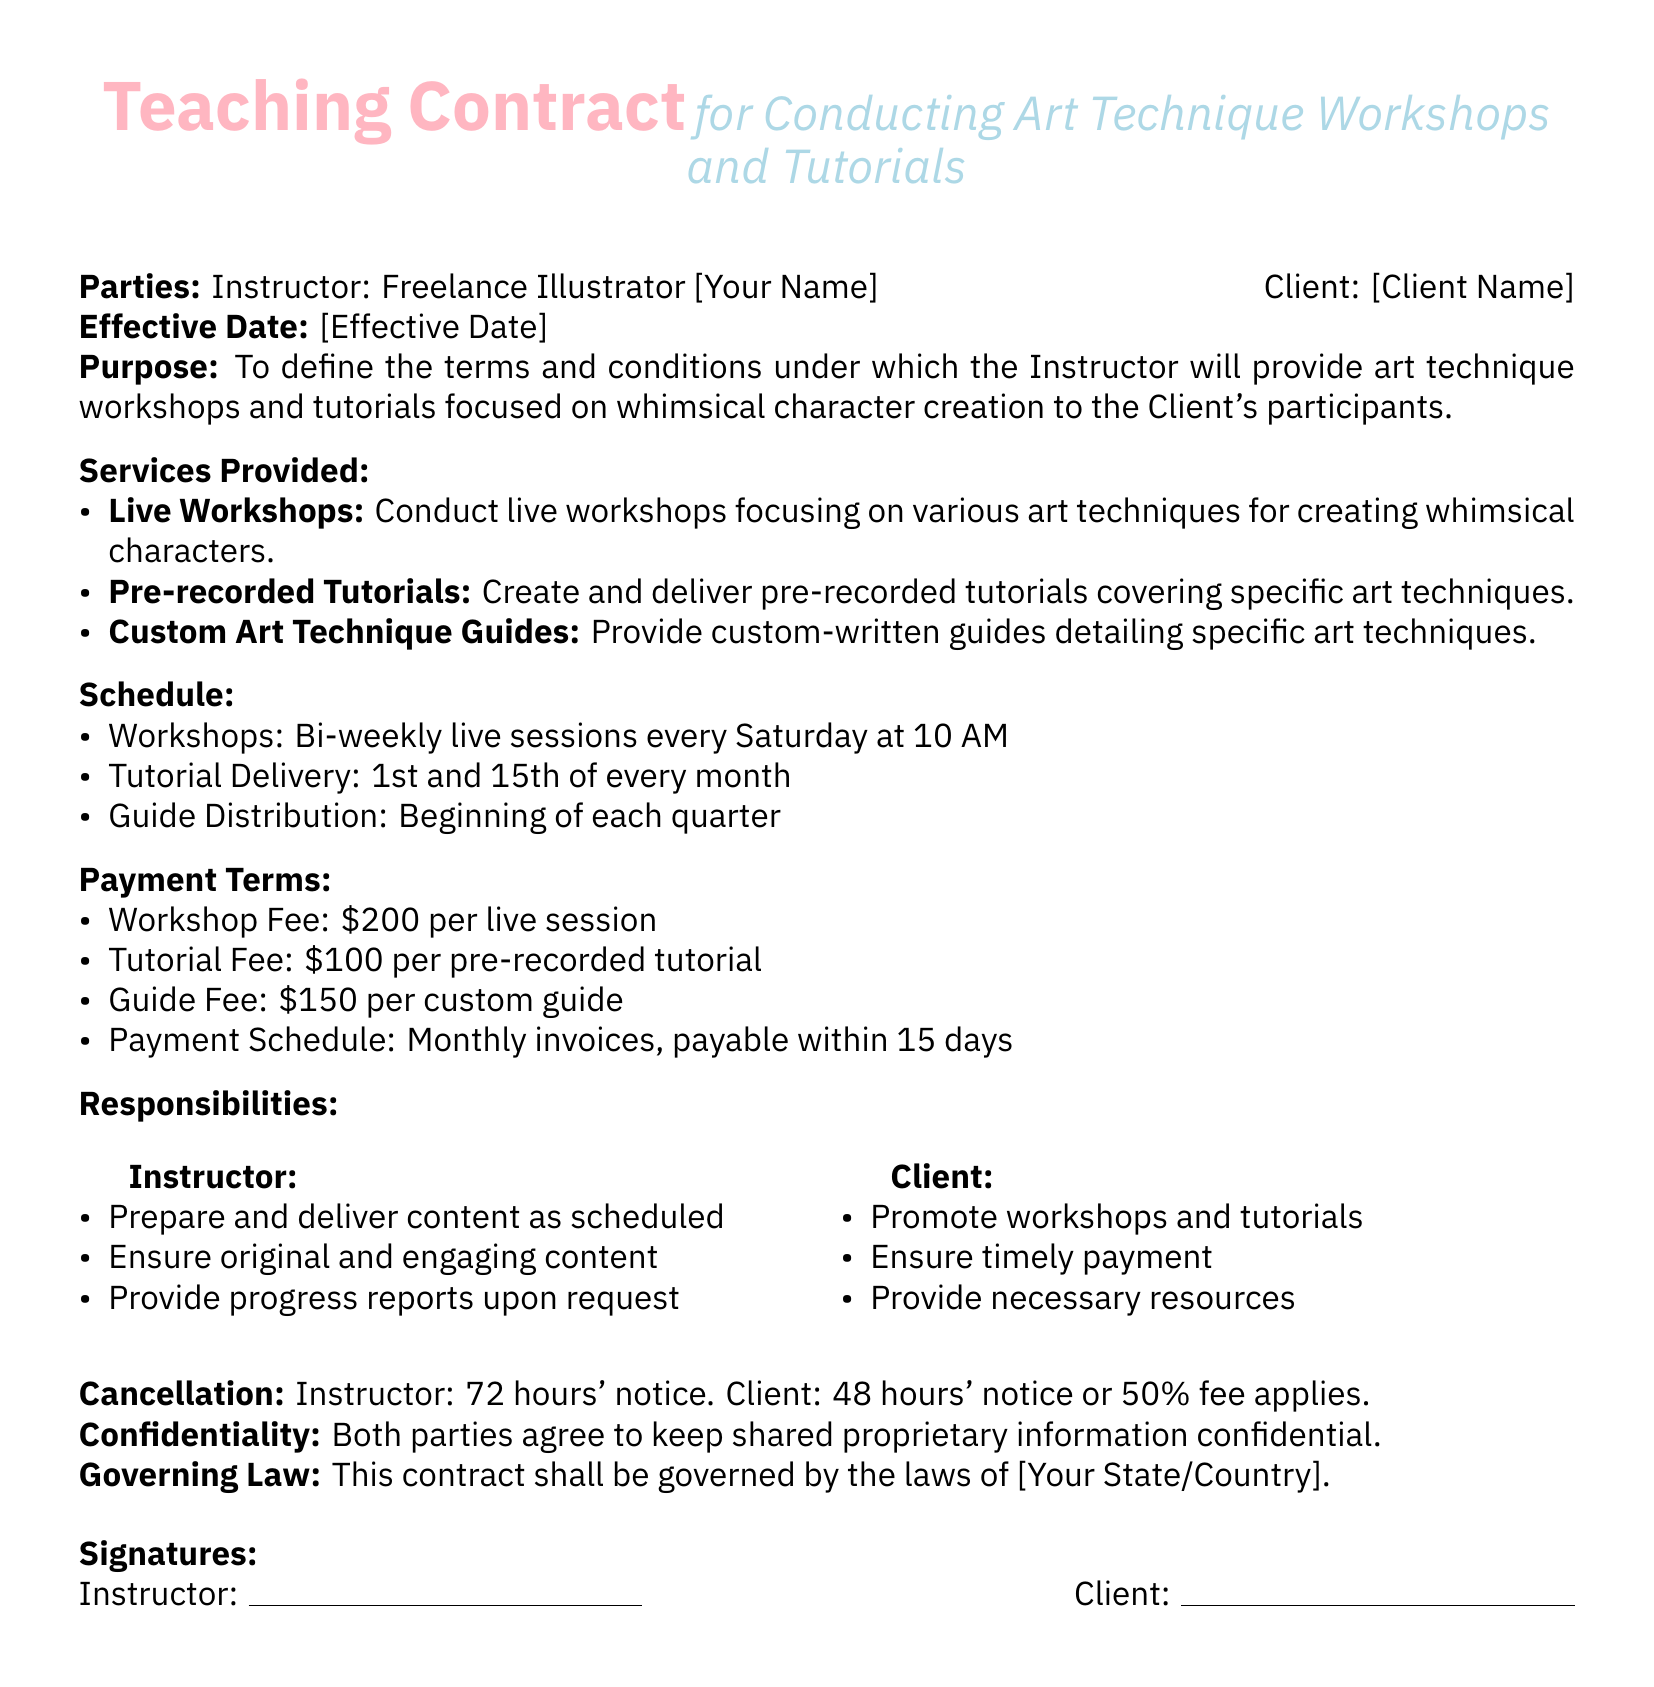What is the contract's effective date? The effective date is mentioned at the beginning of the contract and it is a placeholder for the actual date to be filled in.
Answer: [Effective Date] Who is the instructor listed in the contract? The instructor's name is indicated in the introductory section of the document as "Freelance Illustrator [Your Name]."
Answer: Freelance Illustrator [Your Name] What is the fee for a live workshop session? The fee for each live workshop session is specified under the payment terms section.
Answer: $200 How often are the workshops scheduled? The scheduling frequency of the workshops is detailed in the schedule section, indicating how often they will be held.
Answer: Bi-weekly What notice period is required for the instructor to cancel a session? This is specified under the cancellation section of the contract with the exact time frame mentioned.
Answer: 72 hours What is the payment schedule for services rendered? The payment schedule details how payments should be processed as specified in the payment terms section.
Answer: Monthly invoices, payable within 15 days What type of content is the instructor required to provide? This is mentioned under the instructor's responsibilities and outlines what needs to be delivered.
Answer: Original and engaging content Which law governs this contract? The governing law clause specifies the jurisdiction relevant to the contract.
Answer: [Your State/Country] What collateral duties does the client have? The duties assigned to the client in the contract outline what responsibilities they must fulfill.
Answer: Promote workshops and tutorials 